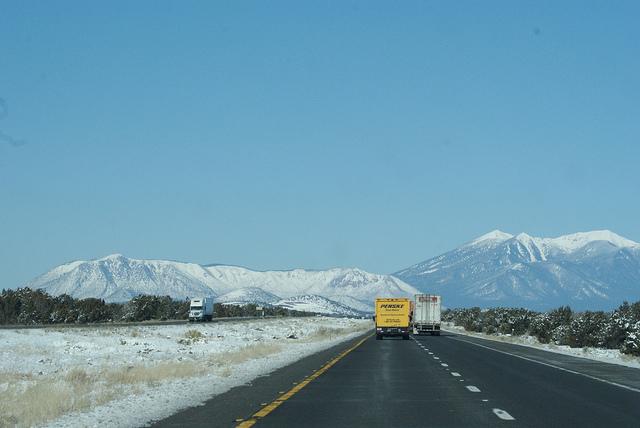Where is this picture taken?
Give a very brief answer. Mountains. Is this picture taken in the midwest?
Keep it brief. No. Is there snow on the mountains?
Keep it brief. Yes. How many trucks are coming towards the camera?
Give a very brief answer. 1. Does this look like a very high altitude?
Answer briefly. Yes. 